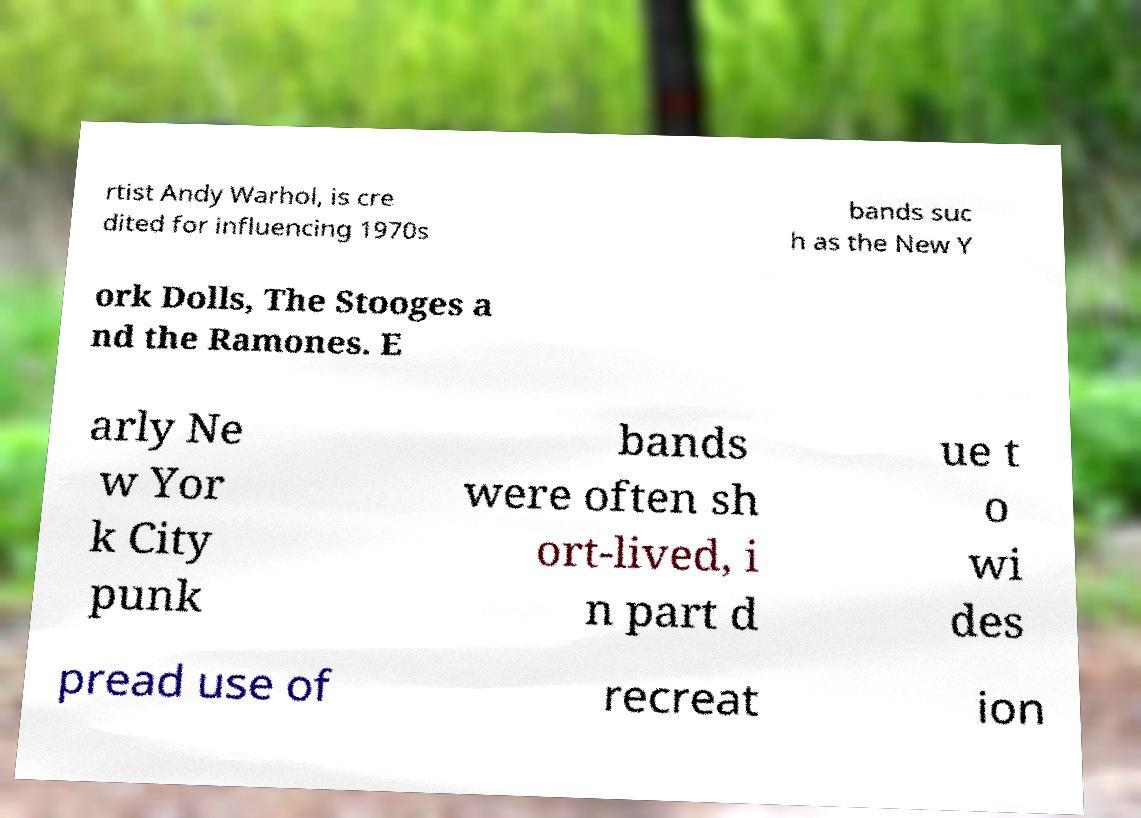Please read and relay the text visible in this image. What does it say? rtist Andy Warhol, is cre dited for influencing 1970s bands suc h as the New Y ork Dolls, The Stooges a nd the Ramones. E arly Ne w Yor k City punk bands were often sh ort-lived, i n part d ue t o wi des pread use of recreat ion 